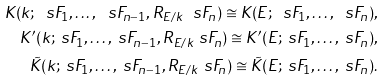<formula> <loc_0><loc_0><loc_500><loc_500>K ( k ; \ s F _ { 1 } , \dots , \ s F _ { n - 1 } , R _ { E / k } \ s F _ { n } ) \cong K ( E ; \ s F _ { 1 } , \dots , \ s F _ { n } ) , \\ K ^ { \prime } ( k ; \ s F _ { 1 } , \dots , \ s F _ { n - 1 } , R _ { E / k } \ s F _ { n } ) \cong K ^ { \prime } ( E ; \ s F _ { 1 } , \dots , \ s F _ { n } ) , \\ \tilde { K } ( k ; \ s F _ { 1 } , \dots , \ s F _ { n - 1 } , R _ { E / k } \ s F _ { n } ) \cong \tilde { K } ( E ; \ s F _ { 1 } , \dots , \ s F _ { n } ) .</formula> 